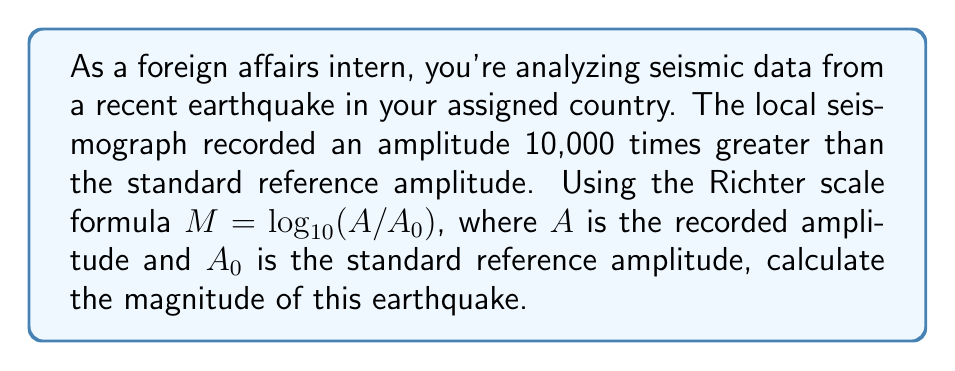Give your solution to this math problem. Let's approach this step-by-step:

1) The Richter scale formula is given as:
   
   $M = \log_{10}(A/A_0)$

2) We're told that the recorded amplitude is 10,000 times greater than the standard reference amplitude. This means:
   
   $A/A_0 = 10,000$

3) We can substitute this into our formula:
   
   $M = \log_{10}(10,000)$

4) Recall that $10,000 = 10^4$. Therefore:
   
   $M = \log_{10}(10^4)$

5) A fundamental property of logarithms states that $\log_a(a^n) = n$. Applying this:
   
   $M = 4$

Thus, the magnitude of the earthquake on the Richter scale is 4.
Answer: 4 